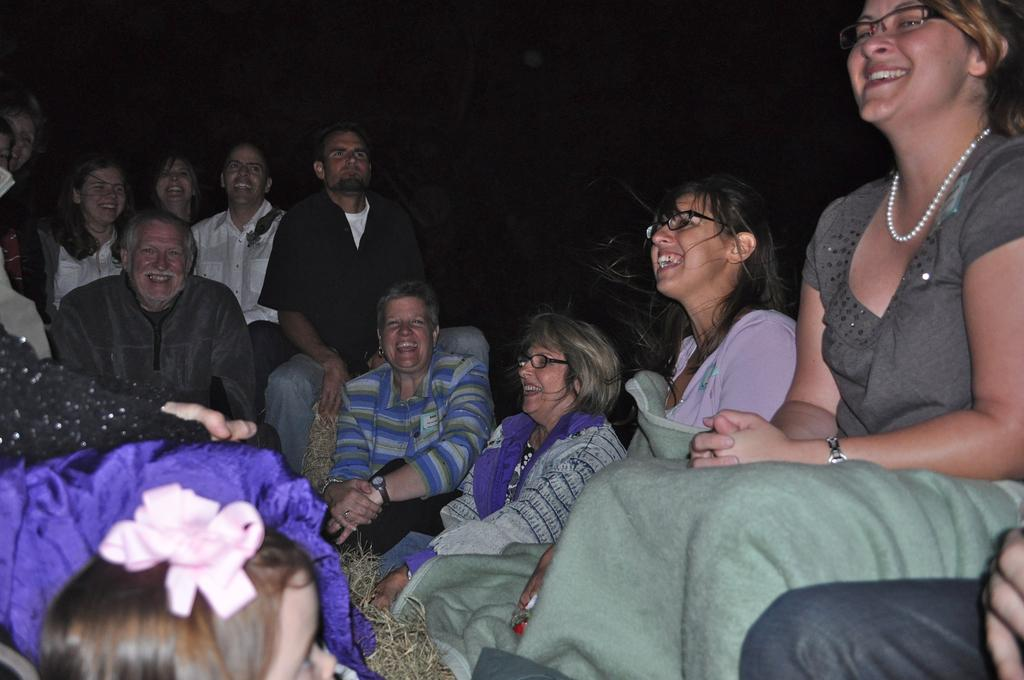What is happening in the image? There is a group of people in the image. What are the people doing? The people are sitting and smiling. What can be seen in the background of the image? The background of the image is dark. What type of scene is depicted in the image? There is no specific scene depicted in the image; it simply shows a group of people sitting and smiling. How many ducks are present in the image? There are no ducks present in the image. 